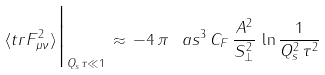<formula> <loc_0><loc_0><loc_500><loc_500>\langle t r F _ { \mu \nu } ^ { 2 } \rangle \Big | _ { Q _ { s } \tau \ll 1 } \, \approx \, - 4 \, \pi \, \ a s ^ { 3 } \, C _ { F } \, \frac { A ^ { 2 } } { S _ { \perp } ^ { 2 } } \, \ln \frac { 1 } { Q _ { s } ^ { 2 } \, \tau ^ { 2 } }</formula> 